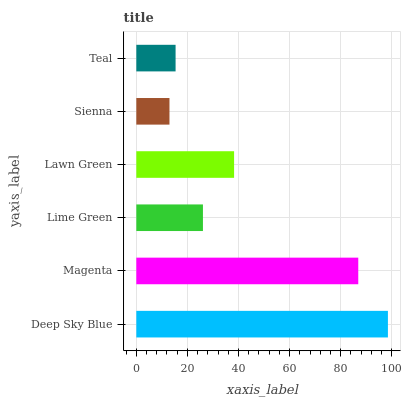Is Sienna the minimum?
Answer yes or no. Yes. Is Deep Sky Blue the maximum?
Answer yes or no. Yes. Is Magenta the minimum?
Answer yes or no. No. Is Magenta the maximum?
Answer yes or no. No. Is Deep Sky Blue greater than Magenta?
Answer yes or no. Yes. Is Magenta less than Deep Sky Blue?
Answer yes or no. Yes. Is Magenta greater than Deep Sky Blue?
Answer yes or no. No. Is Deep Sky Blue less than Magenta?
Answer yes or no. No. Is Lawn Green the high median?
Answer yes or no. Yes. Is Lime Green the low median?
Answer yes or no. Yes. Is Teal the high median?
Answer yes or no. No. Is Magenta the low median?
Answer yes or no. No. 